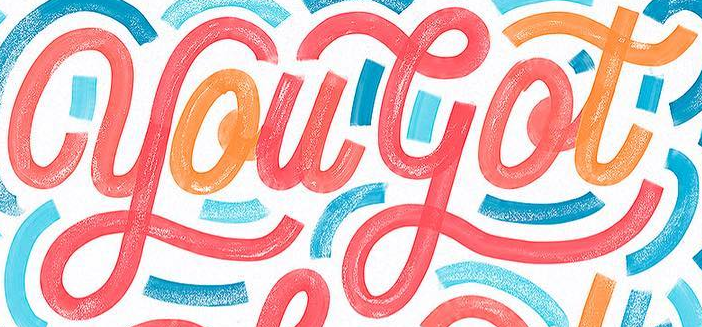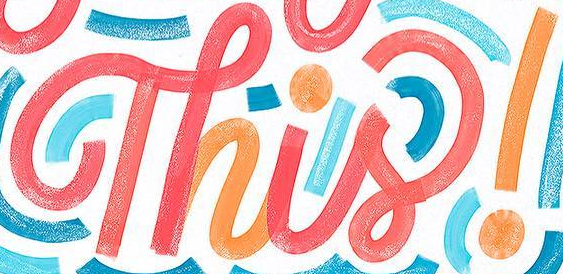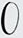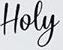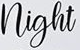Transcribe the words shown in these images in order, separated by a semicolon. yougot; Thisǃ; O; Hoey; night 